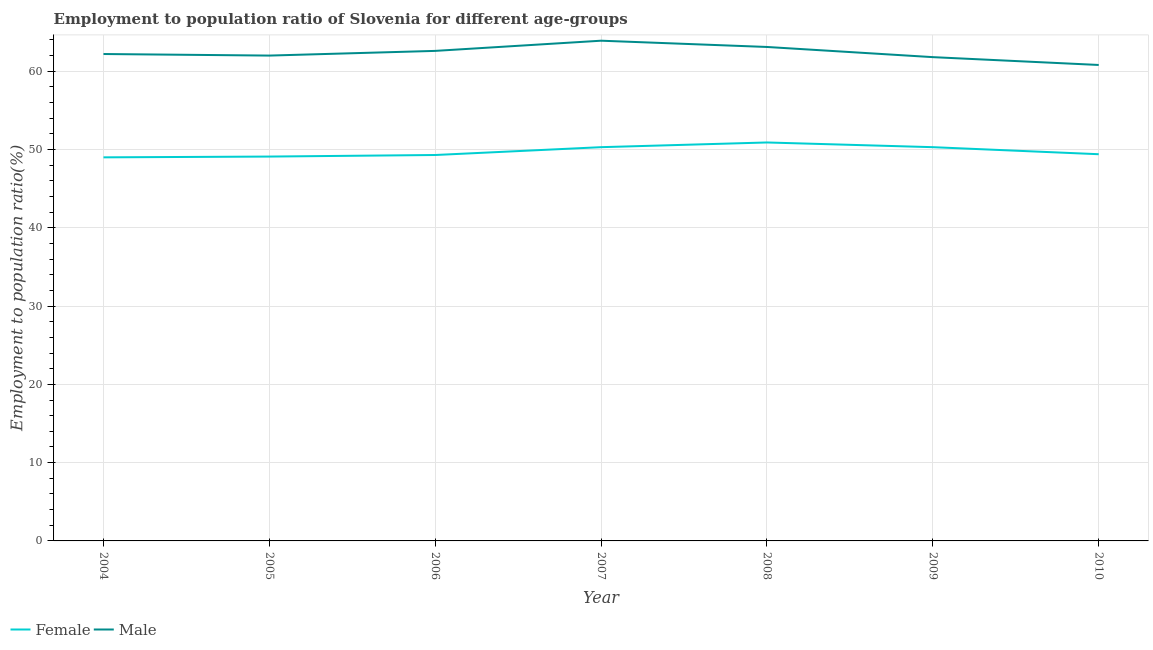Does the line corresponding to employment to population ratio(male) intersect with the line corresponding to employment to population ratio(female)?
Ensure brevity in your answer.  No. Is the number of lines equal to the number of legend labels?
Make the answer very short. Yes. What is the employment to population ratio(female) in 2006?
Your response must be concise. 49.3. Across all years, what is the maximum employment to population ratio(female)?
Ensure brevity in your answer.  50.9. Across all years, what is the minimum employment to population ratio(female)?
Offer a terse response. 49. What is the total employment to population ratio(male) in the graph?
Offer a very short reply. 436.4. What is the difference between the employment to population ratio(male) in 2004 and that in 2008?
Give a very brief answer. -0.9. What is the difference between the employment to population ratio(female) in 2005 and the employment to population ratio(male) in 2006?
Offer a terse response. -13.5. What is the average employment to population ratio(male) per year?
Ensure brevity in your answer.  62.34. In the year 2005, what is the difference between the employment to population ratio(male) and employment to population ratio(female)?
Your response must be concise. 12.9. What is the ratio of the employment to population ratio(male) in 2005 to that in 2009?
Keep it short and to the point. 1. Is the employment to population ratio(male) in 2007 less than that in 2010?
Make the answer very short. No. What is the difference between the highest and the second highest employment to population ratio(female)?
Keep it short and to the point. 0.6. What is the difference between the highest and the lowest employment to population ratio(female)?
Offer a terse response. 1.9. Is the employment to population ratio(male) strictly greater than the employment to population ratio(female) over the years?
Your answer should be very brief. Yes. Does the graph contain any zero values?
Make the answer very short. No. What is the title of the graph?
Offer a very short reply. Employment to population ratio of Slovenia for different age-groups. What is the label or title of the X-axis?
Offer a terse response. Year. What is the Employment to population ratio(%) in Male in 2004?
Offer a very short reply. 62.2. What is the Employment to population ratio(%) in Female in 2005?
Provide a succinct answer. 49.1. What is the Employment to population ratio(%) of Male in 2005?
Make the answer very short. 62. What is the Employment to population ratio(%) in Female in 2006?
Ensure brevity in your answer.  49.3. What is the Employment to population ratio(%) in Male in 2006?
Make the answer very short. 62.6. What is the Employment to population ratio(%) in Female in 2007?
Make the answer very short. 50.3. What is the Employment to population ratio(%) of Male in 2007?
Give a very brief answer. 63.9. What is the Employment to population ratio(%) of Female in 2008?
Offer a very short reply. 50.9. What is the Employment to population ratio(%) in Male in 2008?
Provide a succinct answer. 63.1. What is the Employment to population ratio(%) of Female in 2009?
Keep it short and to the point. 50.3. What is the Employment to population ratio(%) in Male in 2009?
Your answer should be very brief. 61.8. What is the Employment to population ratio(%) of Female in 2010?
Offer a terse response. 49.4. What is the Employment to population ratio(%) of Male in 2010?
Offer a very short reply. 60.8. Across all years, what is the maximum Employment to population ratio(%) in Female?
Keep it short and to the point. 50.9. Across all years, what is the maximum Employment to population ratio(%) in Male?
Offer a terse response. 63.9. Across all years, what is the minimum Employment to population ratio(%) in Female?
Provide a succinct answer. 49. Across all years, what is the minimum Employment to population ratio(%) in Male?
Offer a very short reply. 60.8. What is the total Employment to population ratio(%) of Female in the graph?
Provide a short and direct response. 348.3. What is the total Employment to population ratio(%) of Male in the graph?
Give a very brief answer. 436.4. What is the difference between the Employment to population ratio(%) in Male in 2004 and that in 2005?
Provide a short and direct response. 0.2. What is the difference between the Employment to population ratio(%) of Male in 2004 and that in 2006?
Offer a very short reply. -0.4. What is the difference between the Employment to population ratio(%) of Female in 2004 and that in 2008?
Provide a short and direct response. -1.9. What is the difference between the Employment to population ratio(%) in Male in 2004 and that in 2008?
Your response must be concise. -0.9. What is the difference between the Employment to population ratio(%) of Female in 2004 and that in 2009?
Ensure brevity in your answer.  -1.3. What is the difference between the Employment to population ratio(%) of Male in 2004 and that in 2009?
Your response must be concise. 0.4. What is the difference between the Employment to population ratio(%) in Female in 2004 and that in 2010?
Your response must be concise. -0.4. What is the difference between the Employment to population ratio(%) in Female in 2005 and that in 2006?
Your response must be concise. -0.2. What is the difference between the Employment to population ratio(%) in Male in 2005 and that in 2006?
Ensure brevity in your answer.  -0.6. What is the difference between the Employment to population ratio(%) in Female in 2005 and that in 2007?
Provide a short and direct response. -1.2. What is the difference between the Employment to population ratio(%) in Male in 2005 and that in 2008?
Give a very brief answer. -1.1. What is the difference between the Employment to population ratio(%) in Female in 2005 and that in 2009?
Give a very brief answer. -1.2. What is the difference between the Employment to population ratio(%) of Female in 2005 and that in 2010?
Your answer should be compact. -0.3. What is the difference between the Employment to population ratio(%) in Male in 2006 and that in 2007?
Your response must be concise. -1.3. What is the difference between the Employment to population ratio(%) in Male in 2006 and that in 2008?
Ensure brevity in your answer.  -0.5. What is the difference between the Employment to population ratio(%) in Female in 2006 and that in 2009?
Make the answer very short. -1. What is the difference between the Employment to population ratio(%) in Male in 2006 and that in 2009?
Keep it short and to the point. 0.8. What is the difference between the Employment to population ratio(%) in Female in 2006 and that in 2010?
Your response must be concise. -0.1. What is the difference between the Employment to population ratio(%) of Female in 2007 and that in 2008?
Your answer should be very brief. -0.6. What is the difference between the Employment to population ratio(%) of Male in 2007 and that in 2009?
Your answer should be compact. 2.1. What is the difference between the Employment to population ratio(%) of Male in 2007 and that in 2010?
Ensure brevity in your answer.  3.1. What is the difference between the Employment to population ratio(%) in Female in 2008 and that in 2009?
Keep it short and to the point. 0.6. What is the difference between the Employment to population ratio(%) of Female in 2008 and that in 2010?
Keep it short and to the point. 1.5. What is the difference between the Employment to population ratio(%) in Female in 2004 and the Employment to population ratio(%) in Male in 2005?
Your answer should be compact. -13. What is the difference between the Employment to population ratio(%) of Female in 2004 and the Employment to population ratio(%) of Male in 2006?
Give a very brief answer. -13.6. What is the difference between the Employment to population ratio(%) in Female in 2004 and the Employment to population ratio(%) in Male in 2007?
Give a very brief answer. -14.9. What is the difference between the Employment to population ratio(%) in Female in 2004 and the Employment to population ratio(%) in Male in 2008?
Your answer should be compact. -14.1. What is the difference between the Employment to population ratio(%) in Female in 2004 and the Employment to population ratio(%) in Male in 2009?
Make the answer very short. -12.8. What is the difference between the Employment to population ratio(%) in Female in 2004 and the Employment to population ratio(%) in Male in 2010?
Your response must be concise. -11.8. What is the difference between the Employment to population ratio(%) of Female in 2005 and the Employment to population ratio(%) of Male in 2007?
Provide a short and direct response. -14.8. What is the difference between the Employment to population ratio(%) in Female in 2006 and the Employment to population ratio(%) in Male in 2007?
Your answer should be very brief. -14.6. What is the difference between the Employment to population ratio(%) in Female in 2006 and the Employment to population ratio(%) in Male in 2008?
Your answer should be compact. -13.8. What is the difference between the Employment to population ratio(%) of Female in 2006 and the Employment to population ratio(%) of Male in 2010?
Make the answer very short. -11.5. What is the difference between the Employment to population ratio(%) in Female in 2007 and the Employment to population ratio(%) in Male in 2010?
Keep it short and to the point. -10.5. What is the difference between the Employment to population ratio(%) in Female in 2008 and the Employment to population ratio(%) in Male in 2009?
Your answer should be compact. -10.9. What is the difference between the Employment to population ratio(%) in Female in 2009 and the Employment to population ratio(%) in Male in 2010?
Make the answer very short. -10.5. What is the average Employment to population ratio(%) of Female per year?
Give a very brief answer. 49.76. What is the average Employment to population ratio(%) in Male per year?
Offer a terse response. 62.34. In the year 2006, what is the difference between the Employment to population ratio(%) of Female and Employment to population ratio(%) of Male?
Your answer should be very brief. -13.3. In the year 2009, what is the difference between the Employment to population ratio(%) of Female and Employment to population ratio(%) of Male?
Provide a short and direct response. -11.5. In the year 2010, what is the difference between the Employment to population ratio(%) in Female and Employment to population ratio(%) in Male?
Keep it short and to the point. -11.4. What is the ratio of the Employment to population ratio(%) in Female in 2004 to that in 2005?
Keep it short and to the point. 1. What is the ratio of the Employment to population ratio(%) in Female in 2004 to that in 2007?
Provide a short and direct response. 0.97. What is the ratio of the Employment to population ratio(%) of Male in 2004 to that in 2007?
Your response must be concise. 0.97. What is the ratio of the Employment to population ratio(%) in Female in 2004 to that in 2008?
Offer a terse response. 0.96. What is the ratio of the Employment to population ratio(%) in Male in 2004 to that in 2008?
Provide a short and direct response. 0.99. What is the ratio of the Employment to population ratio(%) of Female in 2004 to that in 2009?
Your answer should be very brief. 0.97. What is the ratio of the Employment to population ratio(%) in Female in 2004 to that in 2010?
Provide a succinct answer. 0.99. What is the ratio of the Employment to population ratio(%) of Female in 2005 to that in 2006?
Keep it short and to the point. 1. What is the ratio of the Employment to population ratio(%) in Male in 2005 to that in 2006?
Your answer should be compact. 0.99. What is the ratio of the Employment to population ratio(%) of Female in 2005 to that in 2007?
Offer a very short reply. 0.98. What is the ratio of the Employment to population ratio(%) of Male in 2005 to that in 2007?
Your response must be concise. 0.97. What is the ratio of the Employment to population ratio(%) of Female in 2005 to that in 2008?
Make the answer very short. 0.96. What is the ratio of the Employment to population ratio(%) of Male in 2005 to that in 2008?
Your response must be concise. 0.98. What is the ratio of the Employment to population ratio(%) in Female in 2005 to that in 2009?
Your answer should be compact. 0.98. What is the ratio of the Employment to population ratio(%) in Male in 2005 to that in 2009?
Offer a very short reply. 1. What is the ratio of the Employment to population ratio(%) of Male in 2005 to that in 2010?
Give a very brief answer. 1.02. What is the ratio of the Employment to population ratio(%) of Female in 2006 to that in 2007?
Provide a succinct answer. 0.98. What is the ratio of the Employment to population ratio(%) of Male in 2006 to that in 2007?
Provide a short and direct response. 0.98. What is the ratio of the Employment to population ratio(%) in Female in 2006 to that in 2008?
Ensure brevity in your answer.  0.97. What is the ratio of the Employment to population ratio(%) of Male in 2006 to that in 2008?
Give a very brief answer. 0.99. What is the ratio of the Employment to population ratio(%) in Female in 2006 to that in 2009?
Offer a terse response. 0.98. What is the ratio of the Employment to population ratio(%) of Male in 2006 to that in 2009?
Ensure brevity in your answer.  1.01. What is the ratio of the Employment to population ratio(%) in Male in 2006 to that in 2010?
Offer a very short reply. 1.03. What is the ratio of the Employment to population ratio(%) in Male in 2007 to that in 2008?
Offer a terse response. 1.01. What is the ratio of the Employment to population ratio(%) in Female in 2007 to that in 2009?
Your answer should be very brief. 1. What is the ratio of the Employment to population ratio(%) of Male in 2007 to that in 2009?
Your response must be concise. 1.03. What is the ratio of the Employment to population ratio(%) in Female in 2007 to that in 2010?
Your answer should be very brief. 1.02. What is the ratio of the Employment to population ratio(%) in Male in 2007 to that in 2010?
Provide a succinct answer. 1.05. What is the ratio of the Employment to population ratio(%) in Female in 2008 to that in 2009?
Your answer should be compact. 1.01. What is the ratio of the Employment to population ratio(%) in Female in 2008 to that in 2010?
Provide a short and direct response. 1.03. What is the ratio of the Employment to population ratio(%) of Male in 2008 to that in 2010?
Give a very brief answer. 1.04. What is the ratio of the Employment to population ratio(%) of Female in 2009 to that in 2010?
Give a very brief answer. 1.02. What is the ratio of the Employment to population ratio(%) in Male in 2009 to that in 2010?
Provide a succinct answer. 1.02. What is the difference between the highest and the second highest Employment to population ratio(%) of Male?
Provide a short and direct response. 0.8. What is the difference between the highest and the lowest Employment to population ratio(%) in Female?
Your response must be concise. 1.9. 